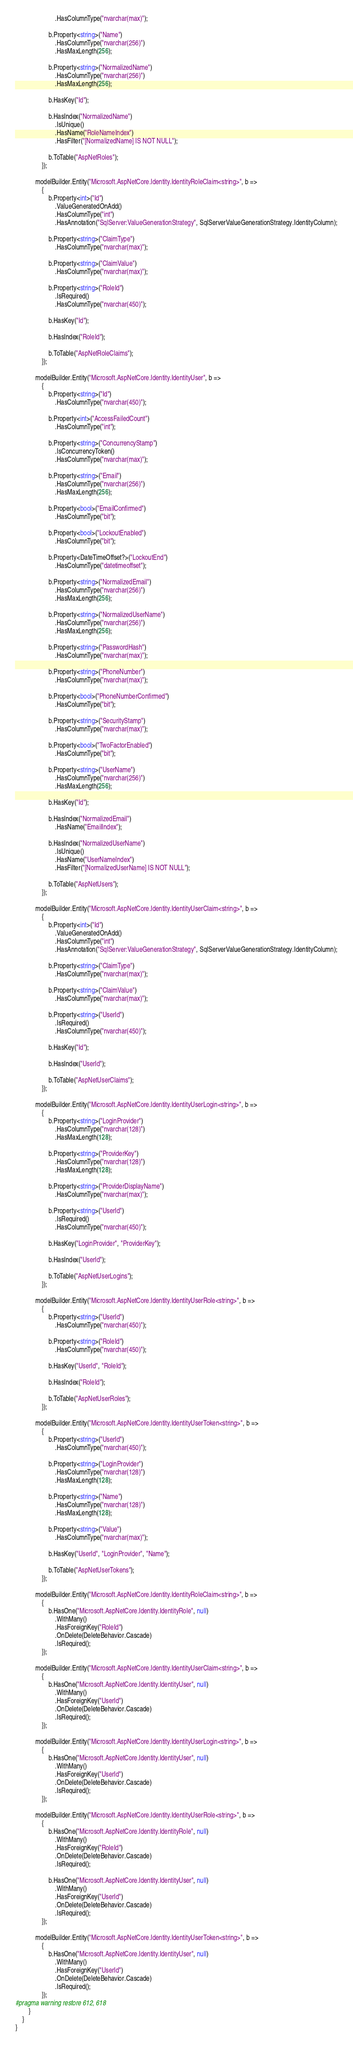<code> <loc_0><loc_0><loc_500><loc_500><_C#_>                        .HasColumnType("nvarchar(max)");

                    b.Property<string>("Name")
                        .HasColumnType("nvarchar(256)")
                        .HasMaxLength(256);

                    b.Property<string>("NormalizedName")
                        .HasColumnType("nvarchar(256)")
                        .HasMaxLength(256);

                    b.HasKey("Id");

                    b.HasIndex("NormalizedName")
                        .IsUnique()
                        .HasName("RoleNameIndex")
                        .HasFilter("[NormalizedName] IS NOT NULL");

                    b.ToTable("AspNetRoles");
                });

            modelBuilder.Entity("Microsoft.AspNetCore.Identity.IdentityRoleClaim<string>", b =>
                {
                    b.Property<int>("Id")
                        .ValueGeneratedOnAdd()
                        .HasColumnType("int")
                        .HasAnnotation("SqlServer:ValueGenerationStrategy", SqlServerValueGenerationStrategy.IdentityColumn);

                    b.Property<string>("ClaimType")
                        .HasColumnType("nvarchar(max)");

                    b.Property<string>("ClaimValue")
                        .HasColumnType("nvarchar(max)");

                    b.Property<string>("RoleId")
                        .IsRequired()
                        .HasColumnType("nvarchar(450)");

                    b.HasKey("Id");

                    b.HasIndex("RoleId");

                    b.ToTable("AspNetRoleClaims");
                });

            modelBuilder.Entity("Microsoft.AspNetCore.Identity.IdentityUser", b =>
                {
                    b.Property<string>("Id")
                        .HasColumnType("nvarchar(450)");

                    b.Property<int>("AccessFailedCount")
                        .HasColumnType("int");

                    b.Property<string>("ConcurrencyStamp")
                        .IsConcurrencyToken()
                        .HasColumnType("nvarchar(max)");

                    b.Property<string>("Email")
                        .HasColumnType("nvarchar(256)")
                        .HasMaxLength(256);

                    b.Property<bool>("EmailConfirmed")
                        .HasColumnType("bit");

                    b.Property<bool>("LockoutEnabled")
                        .HasColumnType("bit");

                    b.Property<DateTimeOffset?>("LockoutEnd")
                        .HasColumnType("datetimeoffset");

                    b.Property<string>("NormalizedEmail")
                        .HasColumnType("nvarchar(256)")
                        .HasMaxLength(256);

                    b.Property<string>("NormalizedUserName")
                        .HasColumnType("nvarchar(256)")
                        .HasMaxLength(256);

                    b.Property<string>("PasswordHash")
                        .HasColumnType("nvarchar(max)");

                    b.Property<string>("PhoneNumber")
                        .HasColumnType("nvarchar(max)");

                    b.Property<bool>("PhoneNumberConfirmed")
                        .HasColumnType("bit");

                    b.Property<string>("SecurityStamp")
                        .HasColumnType("nvarchar(max)");

                    b.Property<bool>("TwoFactorEnabled")
                        .HasColumnType("bit");

                    b.Property<string>("UserName")
                        .HasColumnType("nvarchar(256)")
                        .HasMaxLength(256);

                    b.HasKey("Id");

                    b.HasIndex("NormalizedEmail")
                        .HasName("EmailIndex");

                    b.HasIndex("NormalizedUserName")
                        .IsUnique()
                        .HasName("UserNameIndex")
                        .HasFilter("[NormalizedUserName] IS NOT NULL");

                    b.ToTable("AspNetUsers");
                });

            modelBuilder.Entity("Microsoft.AspNetCore.Identity.IdentityUserClaim<string>", b =>
                {
                    b.Property<int>("Id")
                        .ValueGeneratedOnAdd()
                        .HasColumnType("int")
                        .HasAnnotation("SqlServer:ValueGenerationStrategy", SqlServerValueGenerationStrategy.IdentityColumn);

                    b.Property<string>("ClaimType")
                        .HasColumnType("nvarchar(max)");

                    b.Property<string>("ClaimValue")
                        .HasColumnType("nvarchar(max)");

                    b.Property<string>("UserId")
                        .IsRequired()
                        .HasColumnType("nvarchar(450)");

                    b.HasKey("Id");

                    b.HasIndex("UserId");

                    b.ToTable("AspNetUserClaims");
                });

            modelBuilder.Entity("Microsoft.AspNetCore.Identity.IdentityUserLogin<string>", b =>
                {
                    b.Property<string>("LoginProvider")
                        .HasColumnType("nvarchar(128)")
                        .HasMaxLength(128);

                    b.Property<string>("ProviderKey")
                        .HasColumnType("nvarchar(128)")
                        .HasMaxLength(128);

                    b.Property<string>("ProviderDisplayName")
                        .HasColumnType("nvarchar(max)");

                    b.Property<string>("UserId")
                        .IsRequired()
                        .HasColumnType("nvarchar(450)");

                    b.HasKey("LoginProvider", "ProviderKey");

                    b.HasIndex("UserId");

                    b.ToTable("AspNetUserLogins");
                });

            modelBuilder.Entity("Microsoft.AspNetCore.Identity.IdentityUserRole<string>", b =>
                {
                    b.Property<string>("UserId")
                        .HasColumnType("nvarchar(450)");

                    b.Property<string>("RoleId")
                        .HasColumnType("nvarchar(450)");

                    b.HasKey("UserId", "RoleId");

                    b.HasIndex("RoleId");

                    b.ToTable("AspNetUserRoles");
                });

            modelBuilder.Entity("Microsoft.AspNetCore.Identity.IdentityUserToken<string>", b =>
                {
                    b.Property<string>("UserId")
                        .HasColumnType("nvarchar(450)");

                    b.Property<string>("LoginProvider")
                        .HasColumnType("nvarchar(128)")
                        .HasMaxLength(128);

                    b.Property<string>("Name")
                        .HasColumnType("nvarchar(128)")
                        .HasMaxLength(128);

                    b.Property<string>("Value")
                        .HasColumnType("nvarchar(max)");

                    b.HasKey("UserId", "LoginProvider", "Name");

                    b.ToTable("AspNetUserTokens");
                });

            modelBuilder.Entity("Microsoft.AspNetCore.Identity.IdentityRoleClaim<string>", b =>
                {
                    b.HasOne("Microsoft.AspNetCore.Identity.IdentityRole", null)
                        .WithMany()
                        .HasForeignKey("RoleId")
                        .OnDelete(DeleteBehavior.Cascade)
                        .IsRequired();
                });

            modelBuilder.Entity("Microsoft.AspNetCore.Identity.IdentityUserClaim<string>", b =>
                {
                    b.HasOne("Microsoft.AspNetCore.Identity.IdentityUser", null)
                        .WithMany()
                        .HasForeignKey("UserId")
                        .OnDelete(DeleteBehavior.Cascade)
                        .IsRequired();
                });

            modelBuilder.Entity("Microsoft.AspNetCore.Identity.IdentityUserLogin<string>", b =>
                {
                    b.HasOne("Microsoft.AspNetCore.Identity.IdentityUser", null)
                        .WithMany()
                        .HasForeignKey("UserId")
                        .OnDelete(DeleteBehavior.Cascade)
                        .IsRequired();
                });

            modelBuilder.Entity("Microsoft.AspNetCore.Identity.IdentityUserRole<string>", b =>
                {
                    b.HasOne("Microsoft.AspNetCore.Identity.IdentityRole", null)
                        .WithMany()
                        .HasForeignKey("RoleId")
                        .OnDelete(DeleteBehavior.Cascade)
                        .IsRequired();

                    b.HasOne("Microsoft.AspNetCore.Identity.IdentityUser", null)
                        .WithMany()
                        .HasForeignKey("UserId")
                        .OnDelete(DeleteBehavior.Cascade)
                        .IsRequired();
                });

            modelBuilder.Entity("Microsoft.AspNetCore.Identity.IdentityUserToken<string>", b =>
                {
                    b.HasOne("Microsoft.AspNetCore.Identity.IdentityUser", null)
                        .WithMany()
                        .HasForeignKey("UserId")
                        .OnDelete(DeleteBehavior.Cascade)
                        .IsRequired();
                });
#pragma warning restore 612, 618
        }
    }
}
</code> 